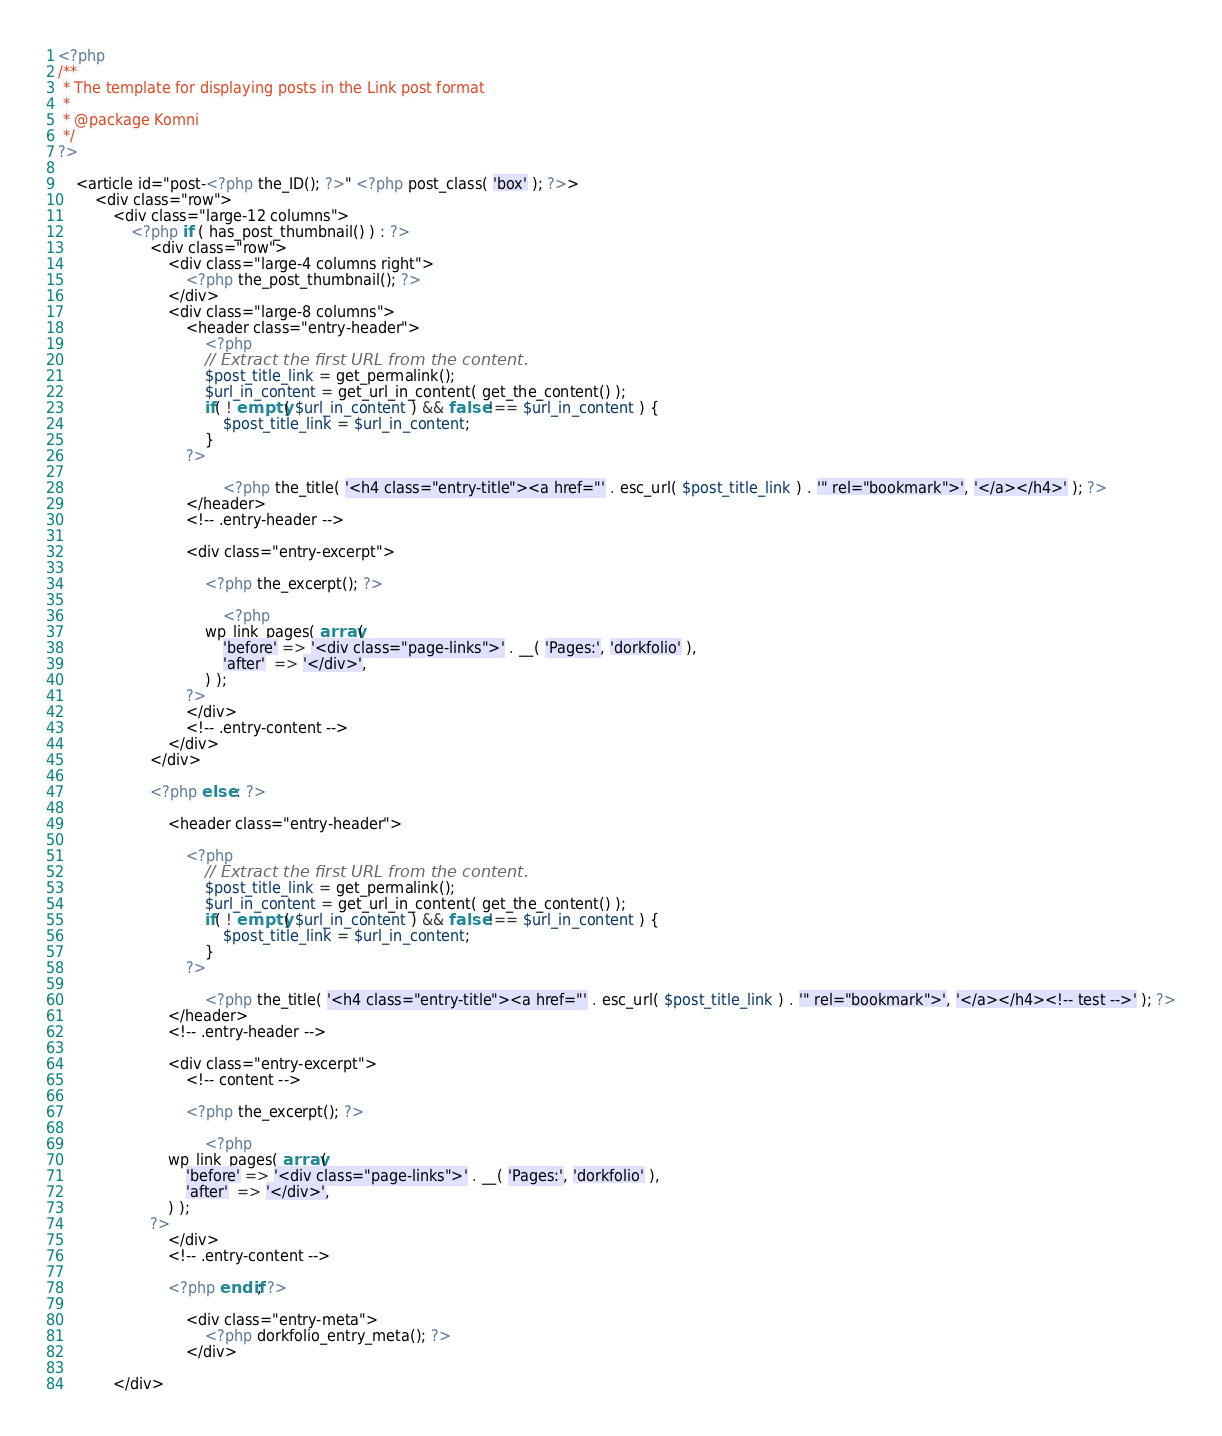<code> <loc_0><loc_0><loc_500><loc_500><_PHP_><?php
/**
 * The template for displaying posts in the Link post format
 *
 * @package Komni
 */
?>

    <article id="post-<?php the_ID(); ?>" <?php post_class( 'box' ); ?>>
        <div class="row">
            <div class="large-12 columns">
                <?php if ( has_post_thumbnail() ) : ?>
                    <div class="row">
                        <div class="large-4 columns right">
                            <?php the_post_thumbnail(); ?>
                        </div>
                        <div class="large-8 columns">
                            <header class="entry-header">
                                <?php
								// Extract the first URL from the content.
								$post_title_link = get_permalink();
								$url_in_content = get_url_in_content( get_the_content() );
								if( ! empty( $url_in_content ) && false !== $url_in_content ) {
									$post_title_link = $url_in_content;
								}
							?>

                                    <?php the_title( '<h4 class="entry-title"><a href="' . esc_url( $post_title_link ) . '" rel="bookmark">', '</a></h4>' ); ?>
                            </header>
                            <!-- .entry-header -->

                            <div class="entry-excerpt">

                                <?php the_excerpt(); ?>

                                    <?php
								wp_link_pages( array(
									'before' => '<div class="page-links">' . __( 'Pages:', 'dorkfolio' ),
									'after'  => '</div>',
								) );
							?>
                            </div>
                            <!-- .entry-content -->
                        </div>
                    </div>

                    <?php else : ?>

                        <header class="entry-header">

                            <?php
								// Extract the first URL from the content.
								$post_title_link = get_permalink();
								$url_in_content = get_url_in_content( get_the_content() );
								if( ! empty( $url_in_content ) && false !== $url_in_content ) {
									$post_title_link = $url_in_content;
								}
							?>

                                <?php the_title( '<h4 class="entry-title"><a href="' . esc_url( $post_title_link ) . '" rel="bookmark">', '</a></h4><!-- test -->' ); ?>
                        </header>
                        <!-- .entry-header -->

                        <div class="entry-excerpt">
                            <!-- content -->

                            <?php the_excerpt(); ?>

                                <?php
						wp_link_pages( array(
							'before' => '<div class="page-links">' . __( 'Pages:', 'dorkfolio' ),
							'after'  => '</div>',
						) );
					?>
                        </div>
                        <!-- .entry-content -->

                        <?php endif; ?>

                            <div class="entry-meta">
                                <?php dorkfolio_entry_meta(); ?>
                            </div>

            </div></code> 